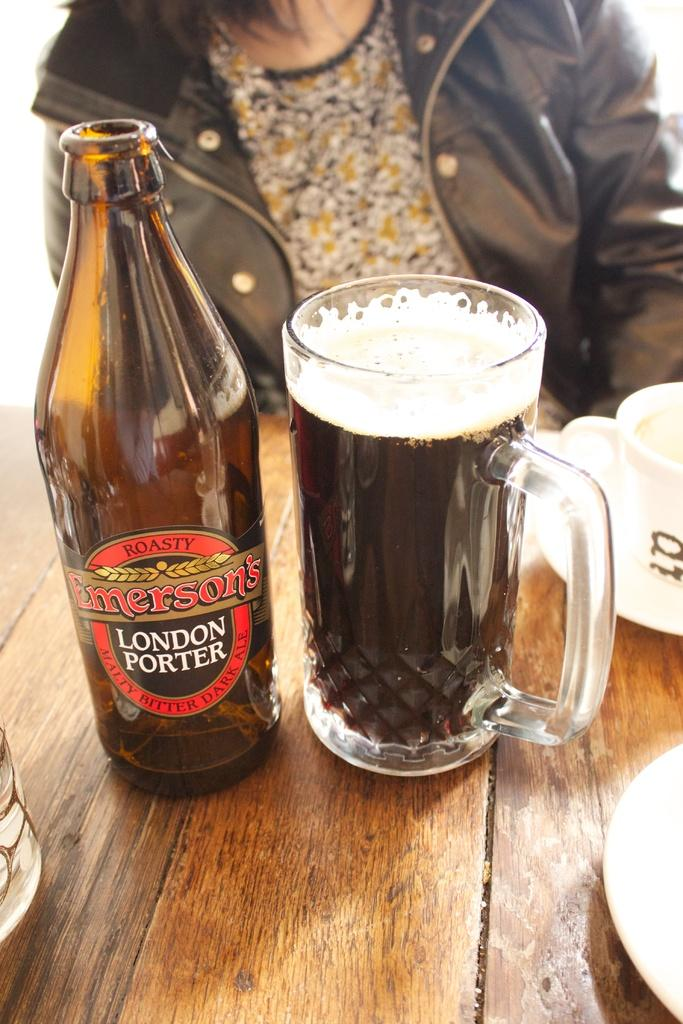<image>
Share a concise interpretation of the image provided. A mug of Emerson's London porter sits next to its bottle. 